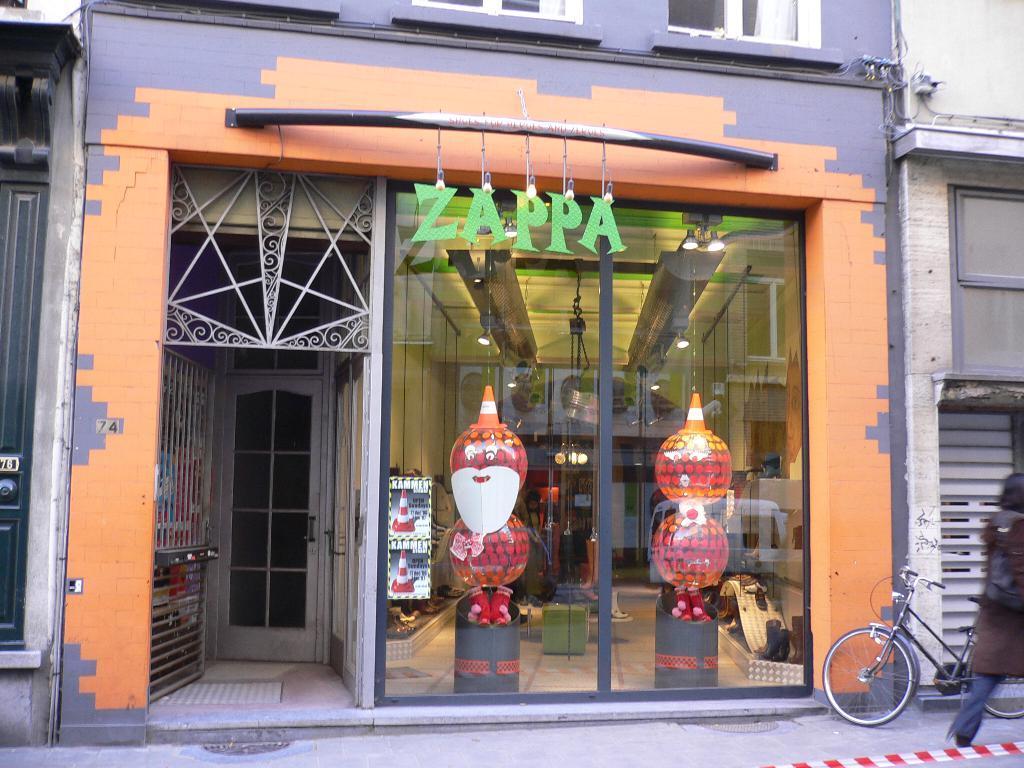Describe this image in one or two sentences. In this image I can see a person and a bicycle. Here I can see a framed glass wall, a door, lights on the ceiling and some other objects. 